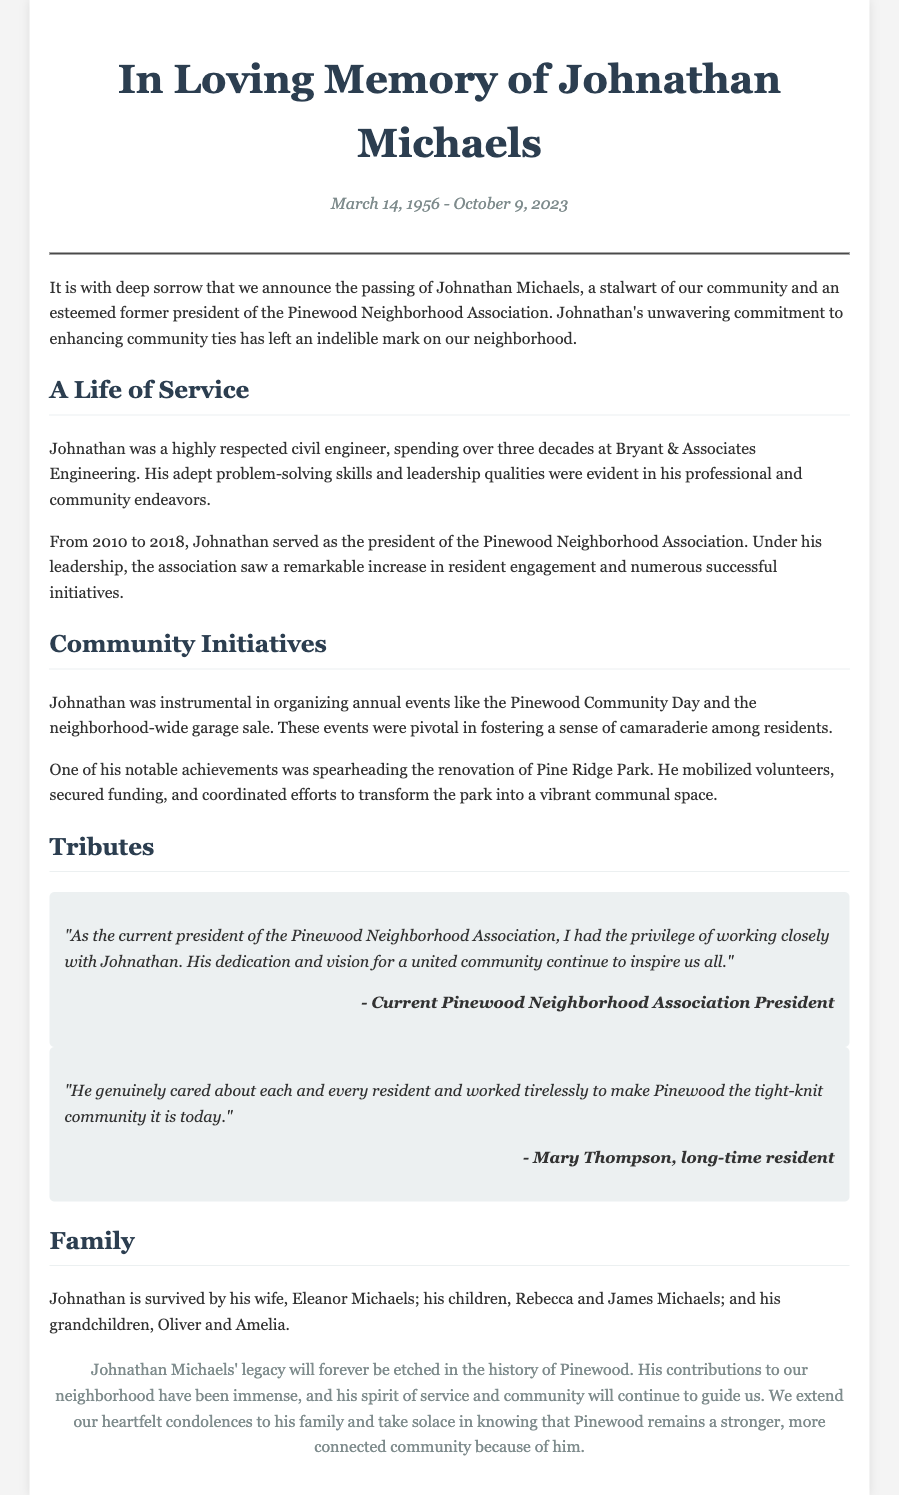What was Johnathan Michaels' profession? The document states that Johnathan was a highly respected civil engineer.
Answer: civil engineer In what years did Johnathan serve as president of the Pinewood Neighborhood Association? The document mentions that he served as president from 2010 to 2018.
Answer: 2010 to 2018 What significant community event did Johnathan organize annually? The obituary notes that he organized the Pinewood Community Day.
Answer: Pinewood Community Day What was one of Johnathan's notable achievements regarding a park? The document highlights that he spearheaded the renovation of Pine Ridge Park.
Answer: renovation of Pine Ridge Park Who is Johnathan's wife? The document states that he is survived by his wife, Eleanor Michaels.
Answer: Eleanor Michaels Why is Johnathan's contribution considered impactful? The obituary mentions that his contributions made Pinewood a stronger, more connected community.
Answer: stronger, more connected community 